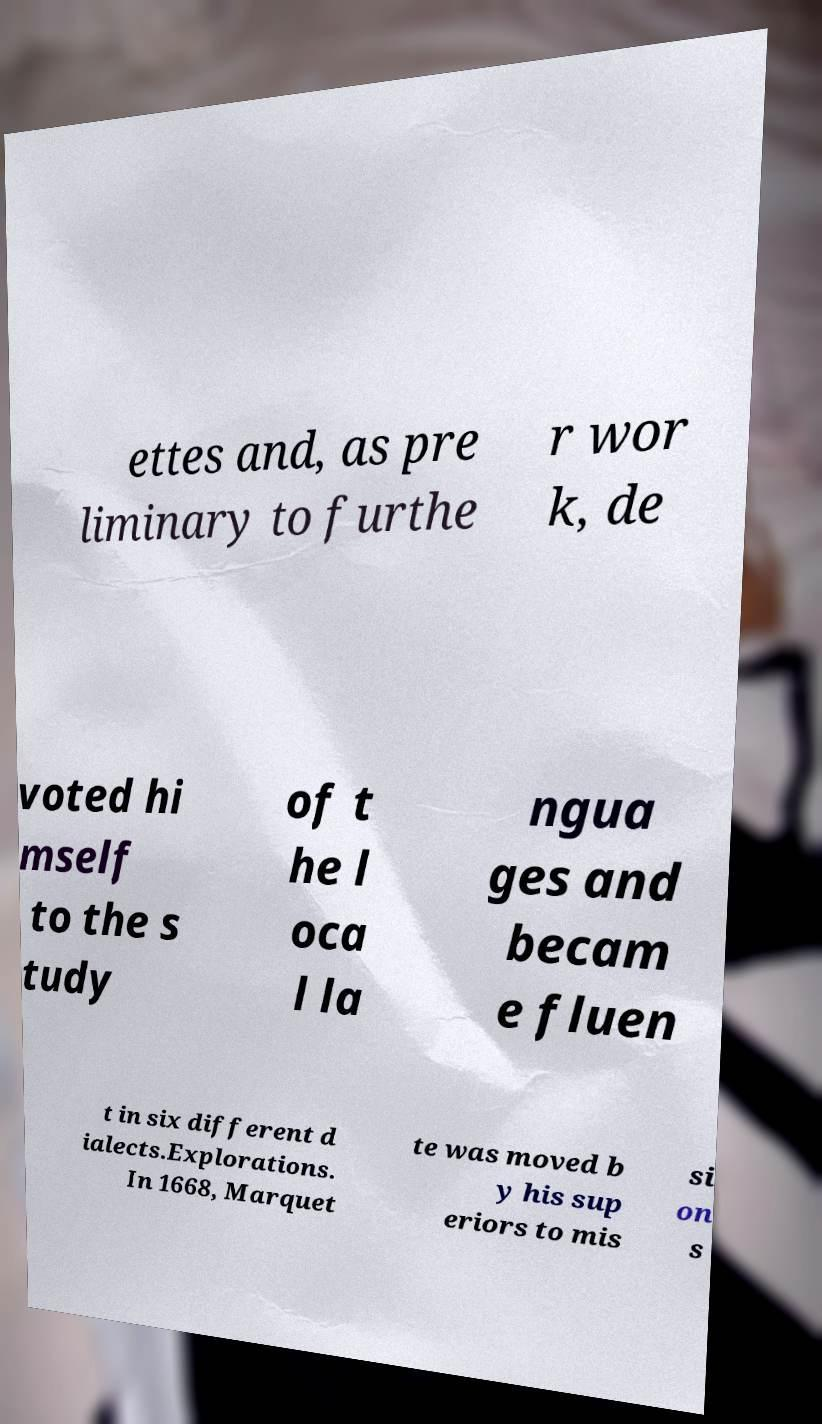Can you accurately transcribe the text from the provided image for me? ettes and, as pre liminary to furthe r wor k, de voted hi mself to the s tudy of t he l oca l la ngua ges and becam e fluen t in six different d ialects.Explorations. In 1668, Marquet te was moved b y his sup eriors to mis si on s 